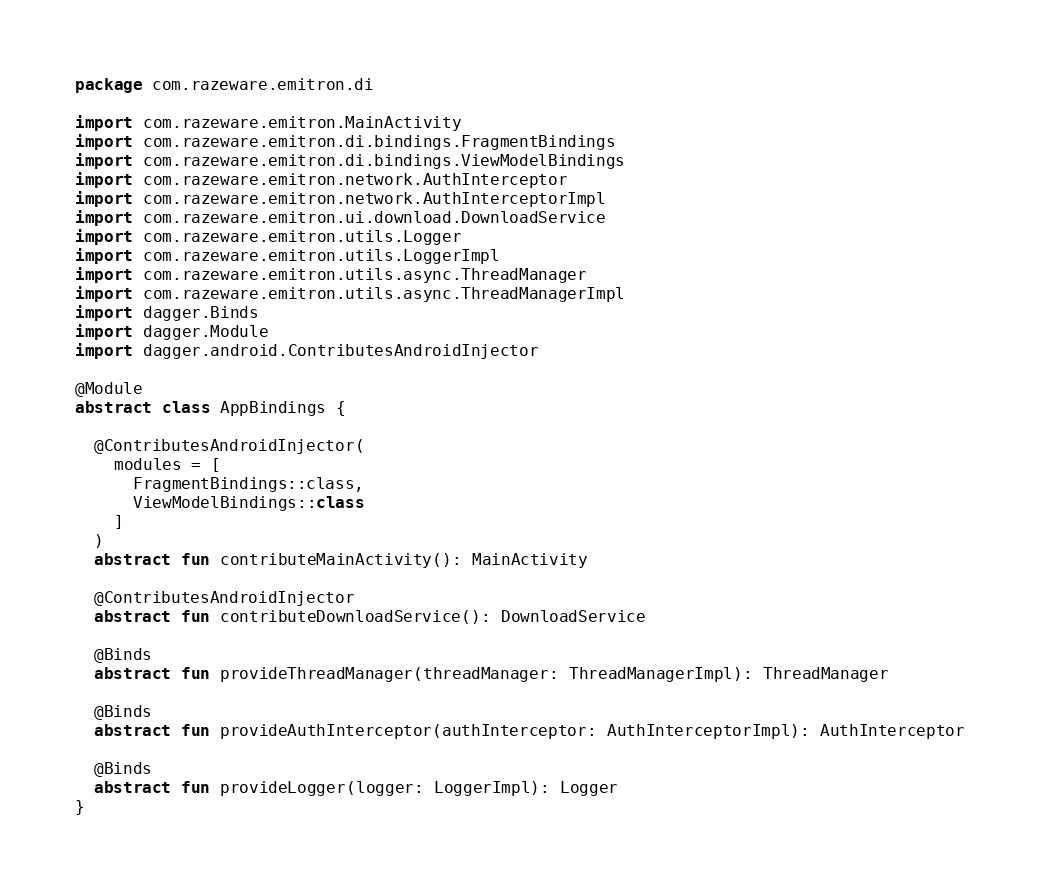<code> <loc_0><loc_0><loc_500><loc_500><_Kotlin_>package com.razeware.emitron.di

import com.razeware.emitron.MainActivity
import com.razeware.emitron.di.bindings.FragmentBindings
import com.razeware.emitron.di.bindings.ViewModelBindings
import com.razeware.emitron.network.AuthInterceptor
import com.razeware.emitron.network.AuthInterceptorImpl
import com.razeware.emitron.ui.download.DownloadService
import com.razeware.emitron.utils.Logger
import com.razeware.emitron.utils.LoggerImpl
import com.razeware.emitron.utils.async.ThreadManager
import com.razeware.emitron.utils.async.ThreadManagerImpl
import dagger.Binds
import dagger.Module
import dagger.android.ContributesAndroidInjector

@Module
abstract class AppBindings {

  @ContributesAndroidInjector(
    modules = [
      FragmentBindings::class,
      ViewModelBindings::class
    ]
  )
  abstract fun contributeMainActivity(): MainActivity

  @ContributesAndroidInjector
  abstract fun contributeDownloadService(): DownloadService

  @Binds
  abstract fun provideThreadManager(threadManager: ThreadManagerImpl): ThreadManager

  @Binds
  abstract fun provideAuthInterceptor(authInterceptor: AuthInterceptorImpl): AuthInterceptor

  @Binds
  abstract fun provideLogger(logger: LoggerImpl): Logger
}

</code> 